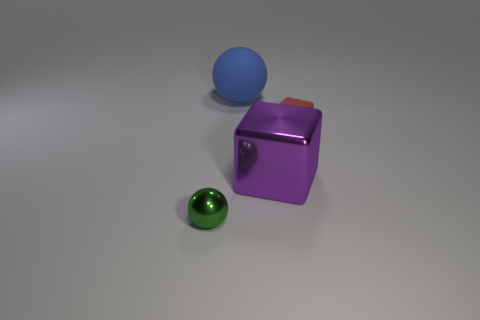The object that is on the right side of the large blue thing and on the left side of the small red rubber thing has what shape?
Offer a very short reply. Cube. Do the large object in front of the blue thing and the matte object that is in front of the blue thing have the same shape?
Ensure brevity in your answer.  Yes. There is a thing that is the same size as the purple block; what is its color?
Provide a short and direct response. Blue. Is the size of the blue thing the same as the purple block?
Make the answer very short. Yes. How many objects are in front of the big rubber object?
Your answer should be very brief. 3. How many things are green balls that are on the left side of the red rubber block or metal cubes?
Offer a very short reply. 2. Is the number of big blue rubber objects in front of the small red rubber thing greater than the number of red matte cubes that are to the left of the blue ball?
Offer a terse response. No. There is a purple thing; is its size the same as the sphere that is behind the small rubber cube?
Offer a very short reply. Yes. How many balls are either large objects or small shiny things?
Offer a terse response. 2. What is the size of the block that is the same material as the large sphere?
Make the answer very short. Small. 